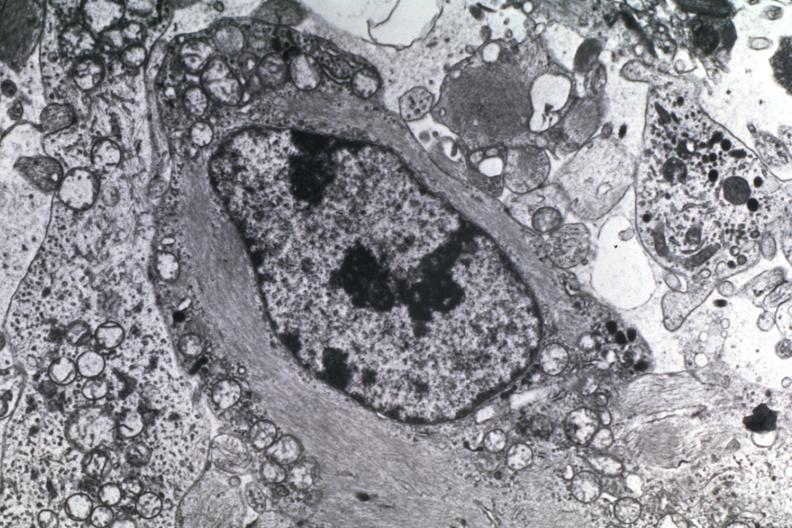what does this image show?
Answer the question using a single word or phrase. Dr garcia tumors 5 